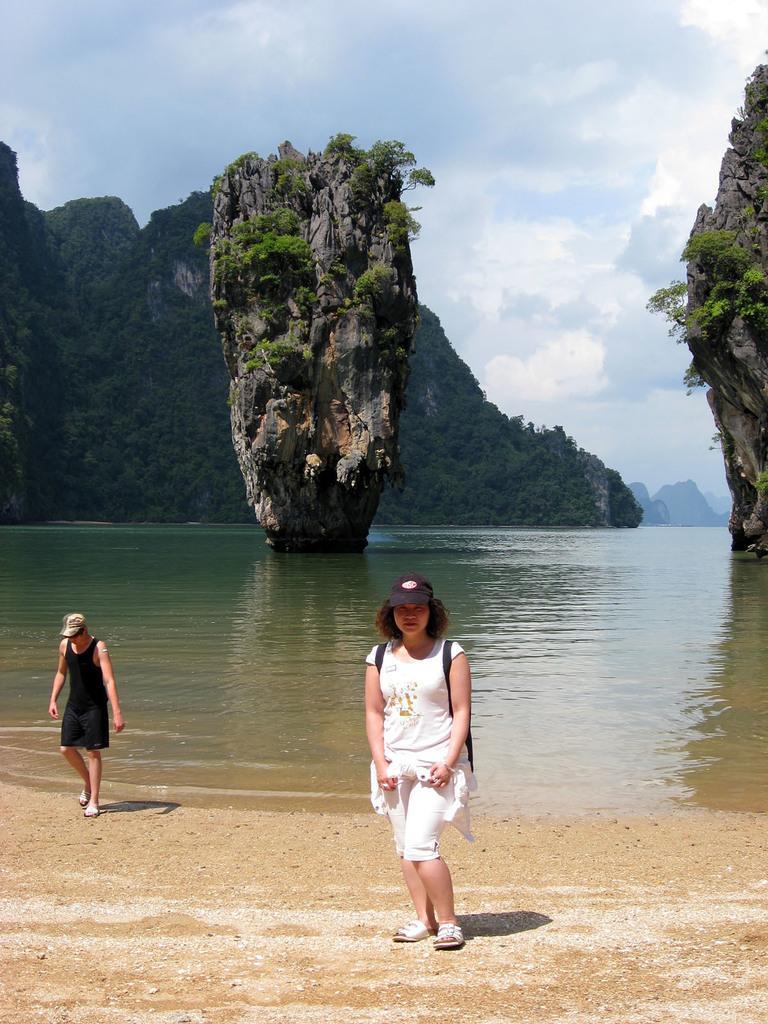Please provide a concise description of this image. In this image I can see two persons. In front the person is wearing white color dress. In the background I can see the water, few rocks, plants in green color, the mountains and the sky is in blue and white color. 